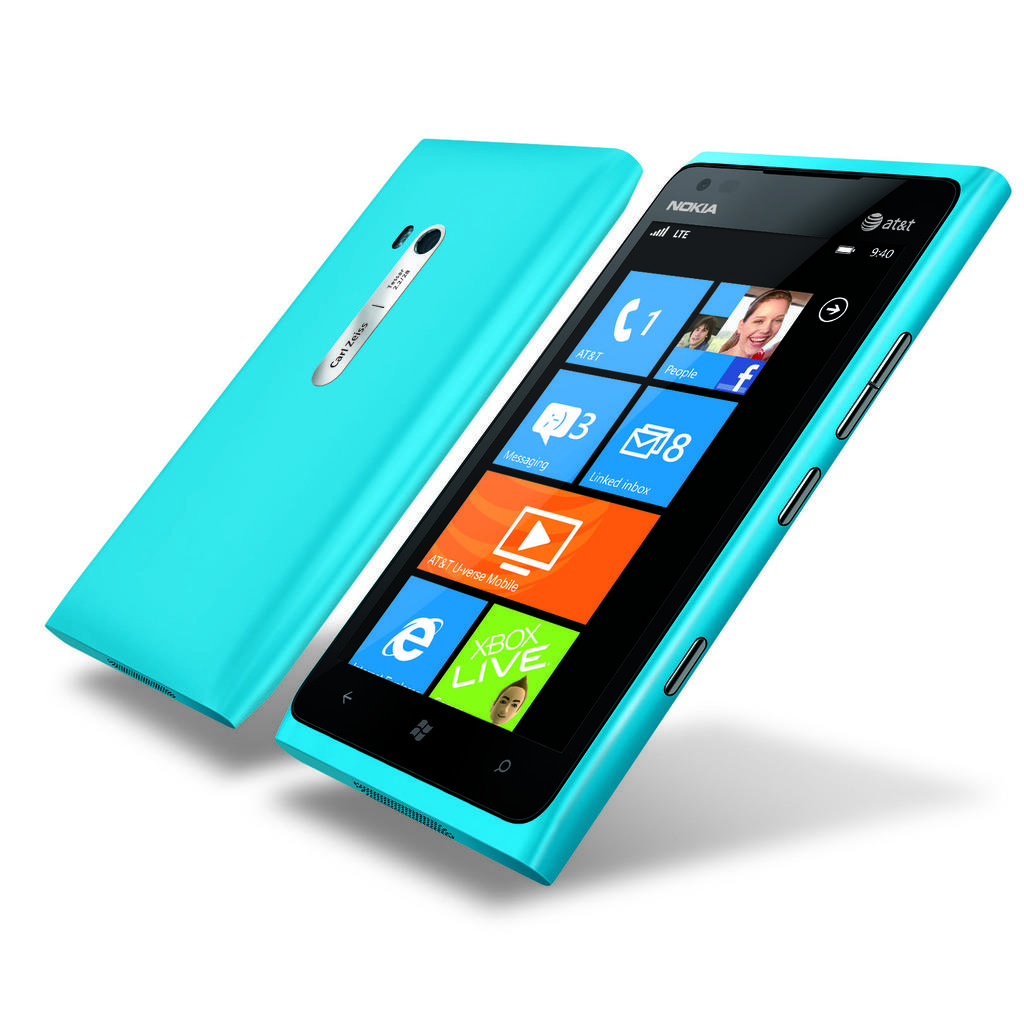How many notifications are on the telephone app?
Your answer should be compact. 1. 